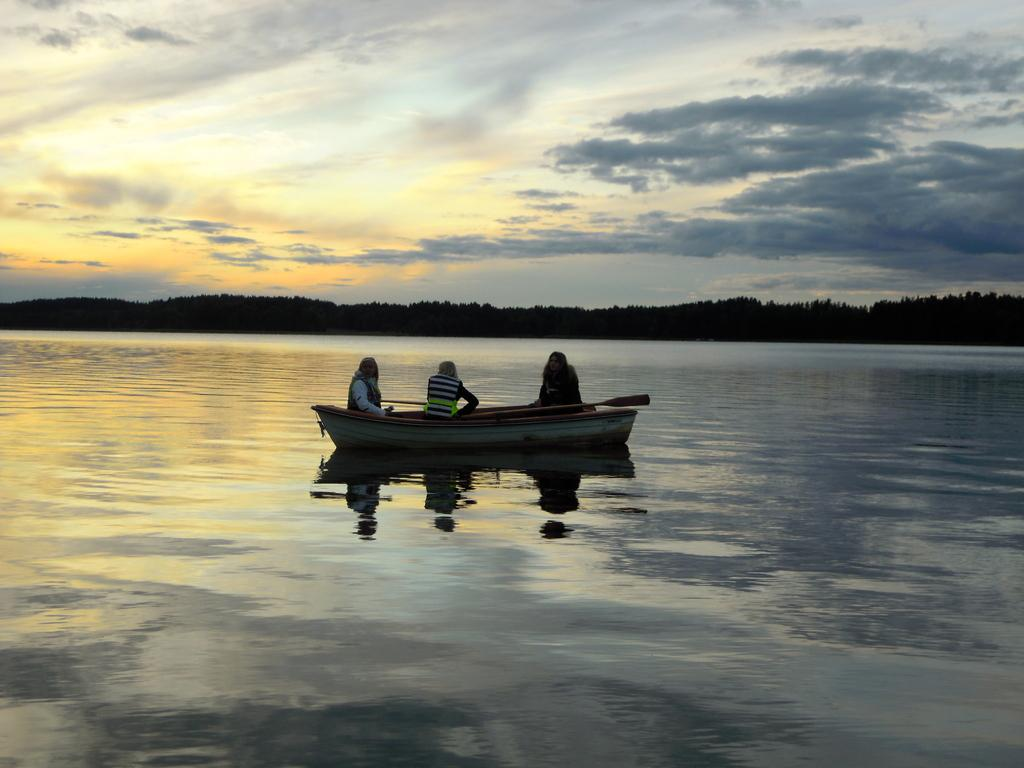What is the main subject of the image? The main subject of the image is a boat. Where is the boat located? The boat is on the water. How many people are on the boat? There are three people on the boat. What can be seen in the background of the image? There are trees in the background of the image. What is visible at the top of the image? The sky is visible at the top of the image. What type of stick is being used by the people on the boat to measure the year? There is no stick or measurement of the year present in the image. The image only shows a boat with three people on it, on the water, with trees in the background and the sky visible at the top. 